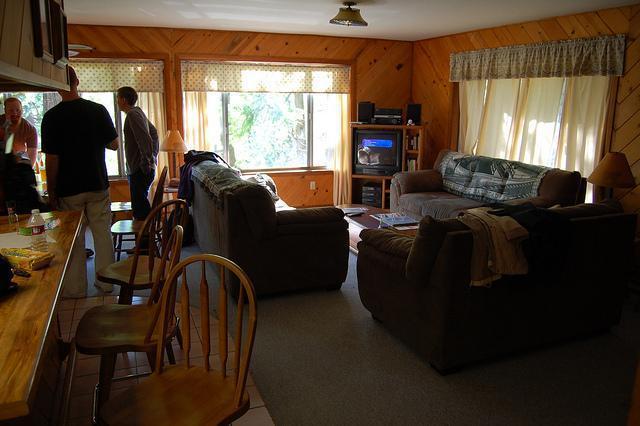How many wooden chairs are there?
Give a very brief answer. 4. How many people can be seen?
Give a very brief answer. 2. How many chairs are there?
Give a very brief answer. 3. How many couches are there?
Give a very brief answer. 3. How many train windows are visible?
Give a very brief answer. 0. 